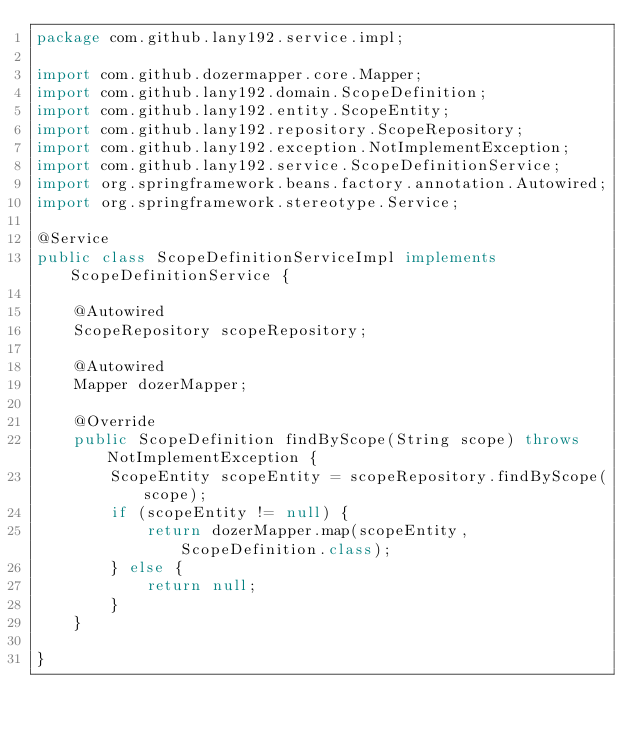Convert code to text. <code><loc_0><loc_0><loc_500><loc_500><_Java_>package com.github.lany192.service.impl;

import com.github.dozermapper.core.Mapper;
import com.github.lany192.domain.ScopeDefinition;
import com.github.lany192.entity.ScopeEntity;
import com.github.lany192.repository.ScopeRepository;
import com.github.lany192.exception.NotImplementException;
import com.github.lany192.service.ScopeDefinitionService;
import org.springframework.beans.factory.annotation.Autowired;
import org.springframework.stereotype.Service;

@Service
public class ScopeDefinitionServiceImpl implements ScopeDefinitionService {

    @Autowired
    ScopeRepository scopeRepository;

    @Autowired
    Mapper dozerMapper;

    @Override
    public ScopeDefinition findByScope(String scope) throws NotImplementException {
        ScopeEntity scopeEntity = scopeRepository.findByScope(scope);
        if (scopeEntity != null) {
            return dozerMapper.map(scopeEntity, ScopeDefinition.class);
        } else {
            return null;
        }
    }

}
</code> 